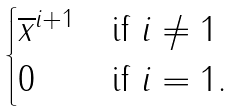Convert formula to latex. <formula><loc_0><loc_0><loc_500><loc_500>\begin{cases} \overline { x } ^ { i + 1 } & \text {if } i \not = 1 \\ 0 & \text {if } i = 1 . \end{cases}</formula> 